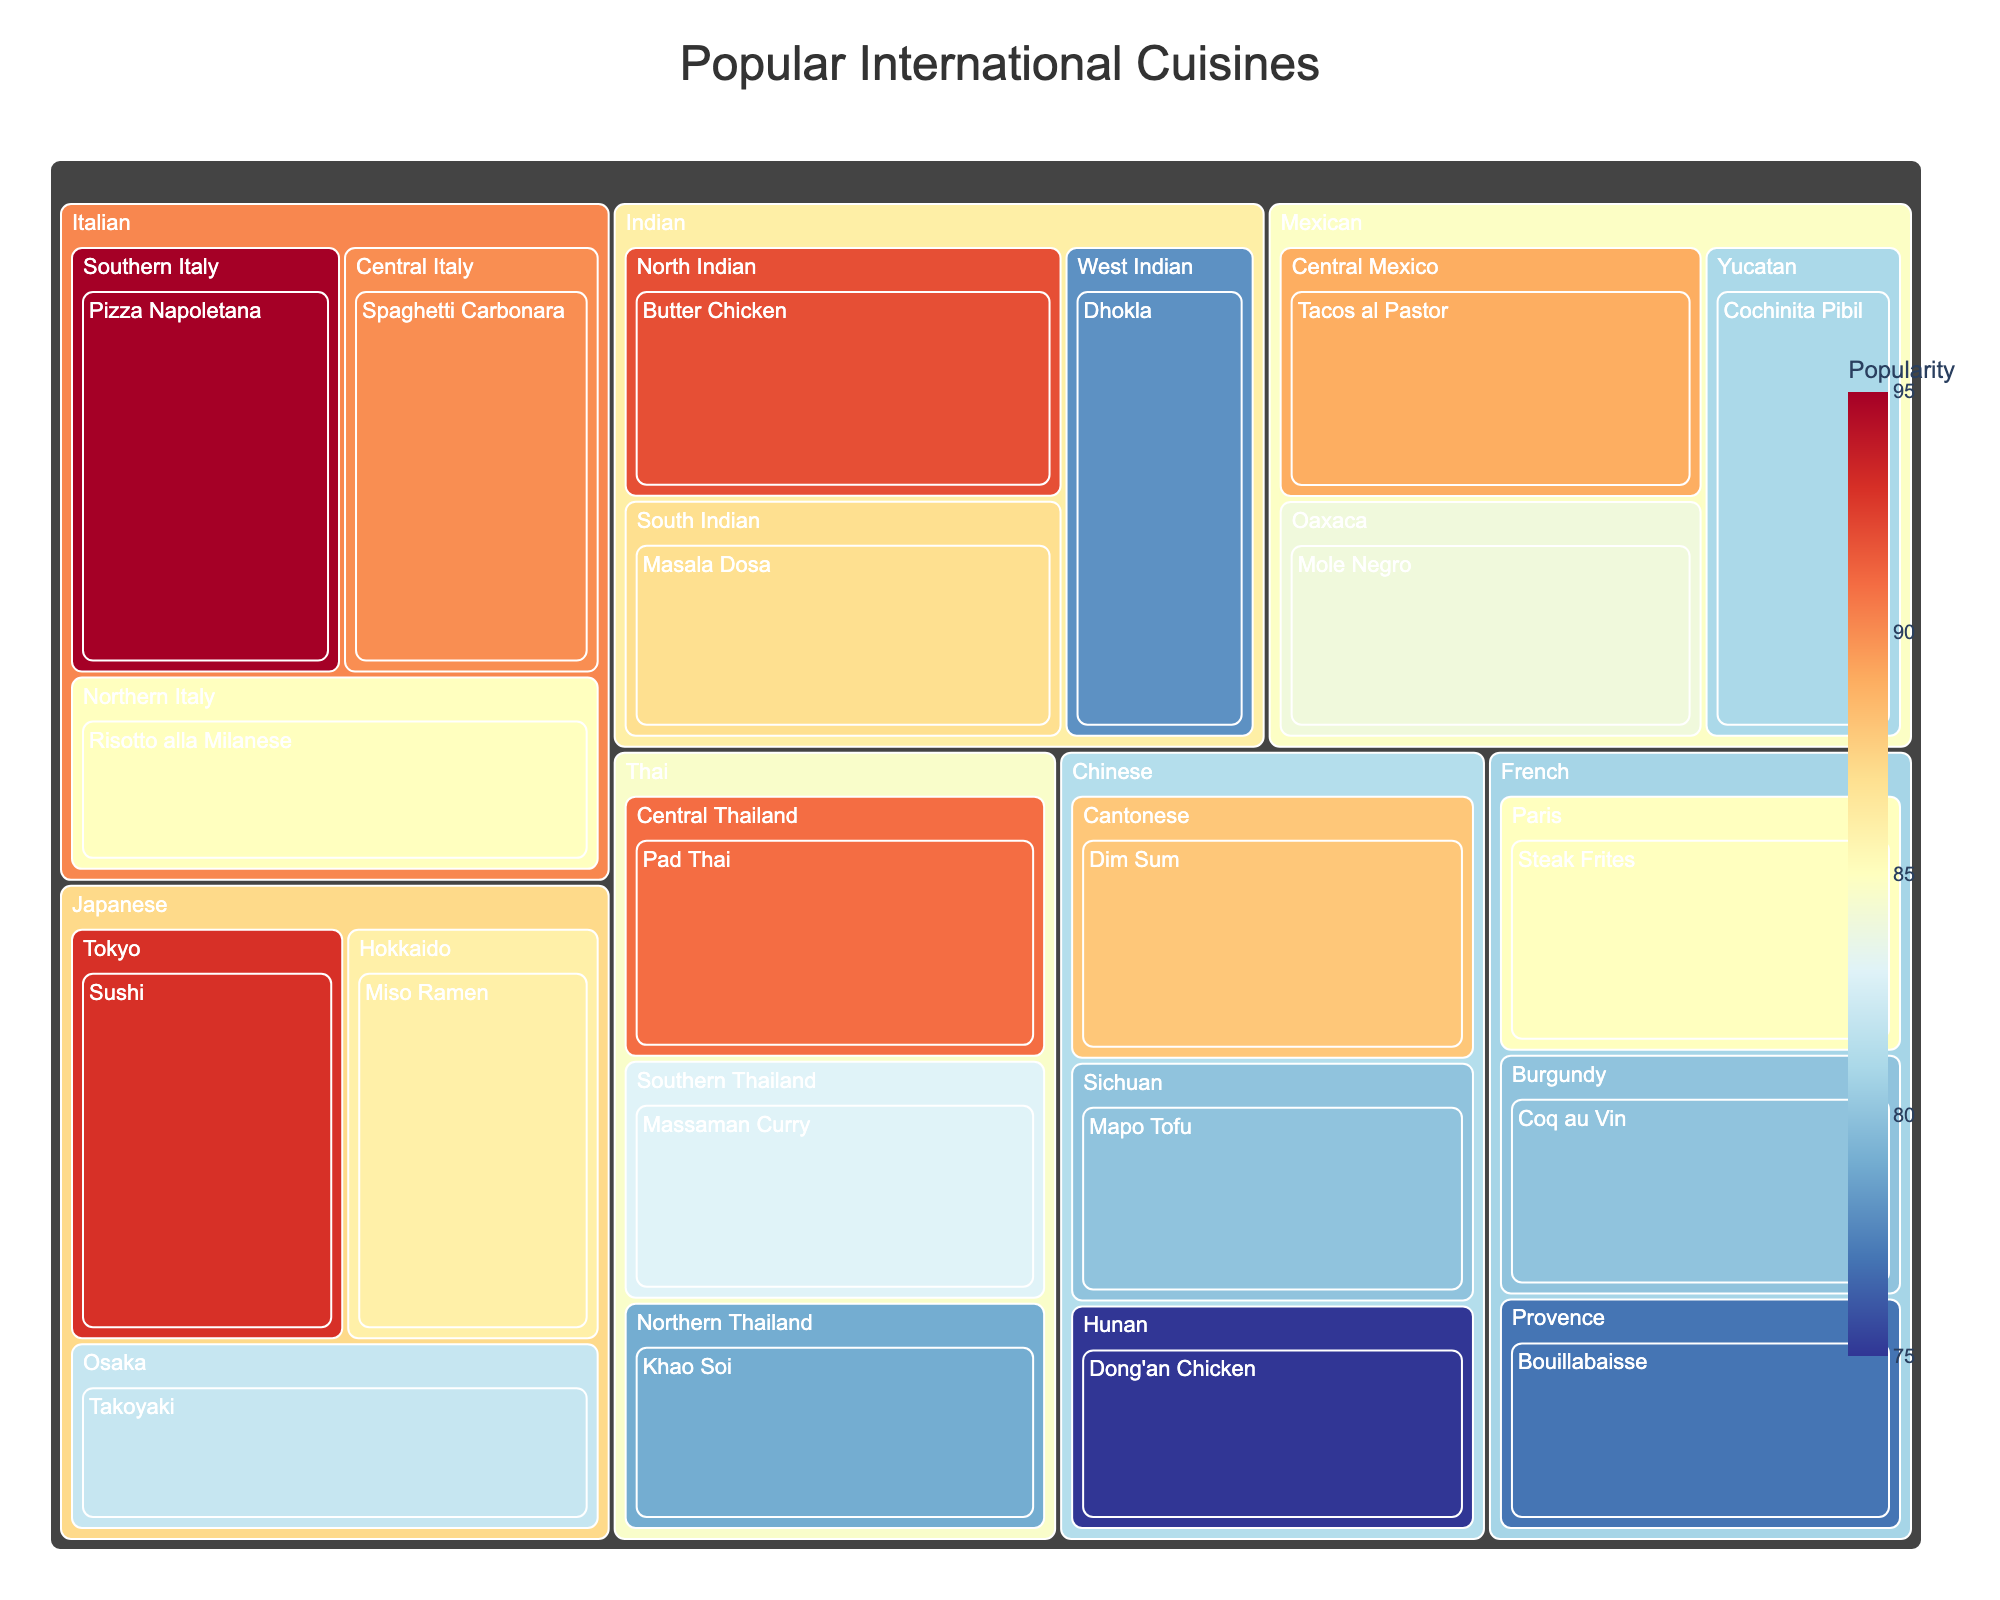What's the title of the Treemap figure? The title is usually placed prominently at the top of the figure. In this case, the title "Popular International Cuisines" is mentioned in the code for generating the plot.
Answer: Popular International Cuisines Which Italian dish has the highest popularity? Examine the sections of the Treemap labeled "Italian," then identify the dish with the highest value. Pizza Napoletana has a popularity of 95.
Answer: Pizza Napoletana Compare the popularity of Pad Thai and Dim Sum. Which one is more popular? Locate the sections labeled "Pad Thai" under "Thai" and "Dim Sum" under "Chinese." Pad Thai has a popularity of 91, while Dim Sum has a popularity of 88.
Answer: Pad Thai What is the combined popularity of Spaghetti Carbonara and Sushi? Locate "Spaghetti Carbonara" under "Italian" and "Sushi" under "Japanese." Their popularities are 90 and 93, respectively. Adding these gives 90 + 93 = 183.
Answer: 183 Which region's dishes are more popular on average, Northern Italy or Southern Italy? Provide the average popularity for each. Northern Italy has "Risotto alla Milanese" (85). Southern Italy has "Pizza Napoletana" (95). Average for Northern Italy is 85. Average for Southern Italy is 95. Compare these averages.
Answer: Southern Italy with an average of 95 Is there any French dish with a popularity of exactly 80? Look under "French" and find the dishes listed. Coq au Vin in Burgundy has a popularity of 80.
Answer: Yes, Coq au Vin What is the least popular dish in the entire Treemap? Identify the dish with the lowest popularity value in the Treemap. Dong'an Chicken from Hunan, China, has a popularity of 75.
Answer: Dong'an Chicken What is the popularity range within the Japanese cuisine? Find the highest and lowest popularity values under "Japanese" cuisine. The range is determined by subtracting the smallest value from the largest. Sushi (93) and Takoyaki (82) and Miso Ramen (86). The range is 93 - 82 = 11.
Answer: 11 How many regions are represented in the Treemap? Count the unique entries under the "Region" level in the Treemap. There are multiple regions listed: Northern Italy, Southern Italy, Central Italy, Sichuan, Cantonese, Hunan, North Indian, South Indian, West Indian, Tokyo, Osaka, Hokkaido, Central Mexico, Yucatan, Oaxaca, Central Thailand, Northern Thailand, Southern Thailand, Provence, Burgundy, Paris. There are 20 regions in total.
Answer: 20 